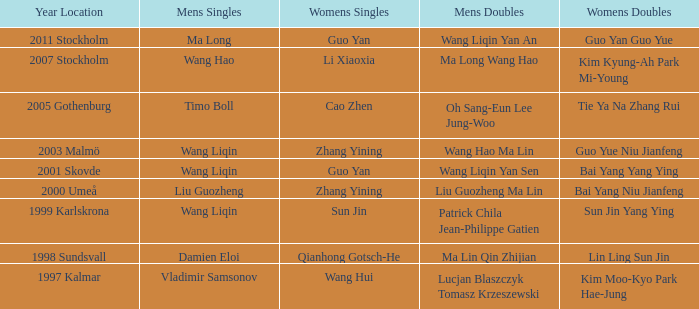How many instances has sun jin claimed victory in the women's doubles? 1.0. 